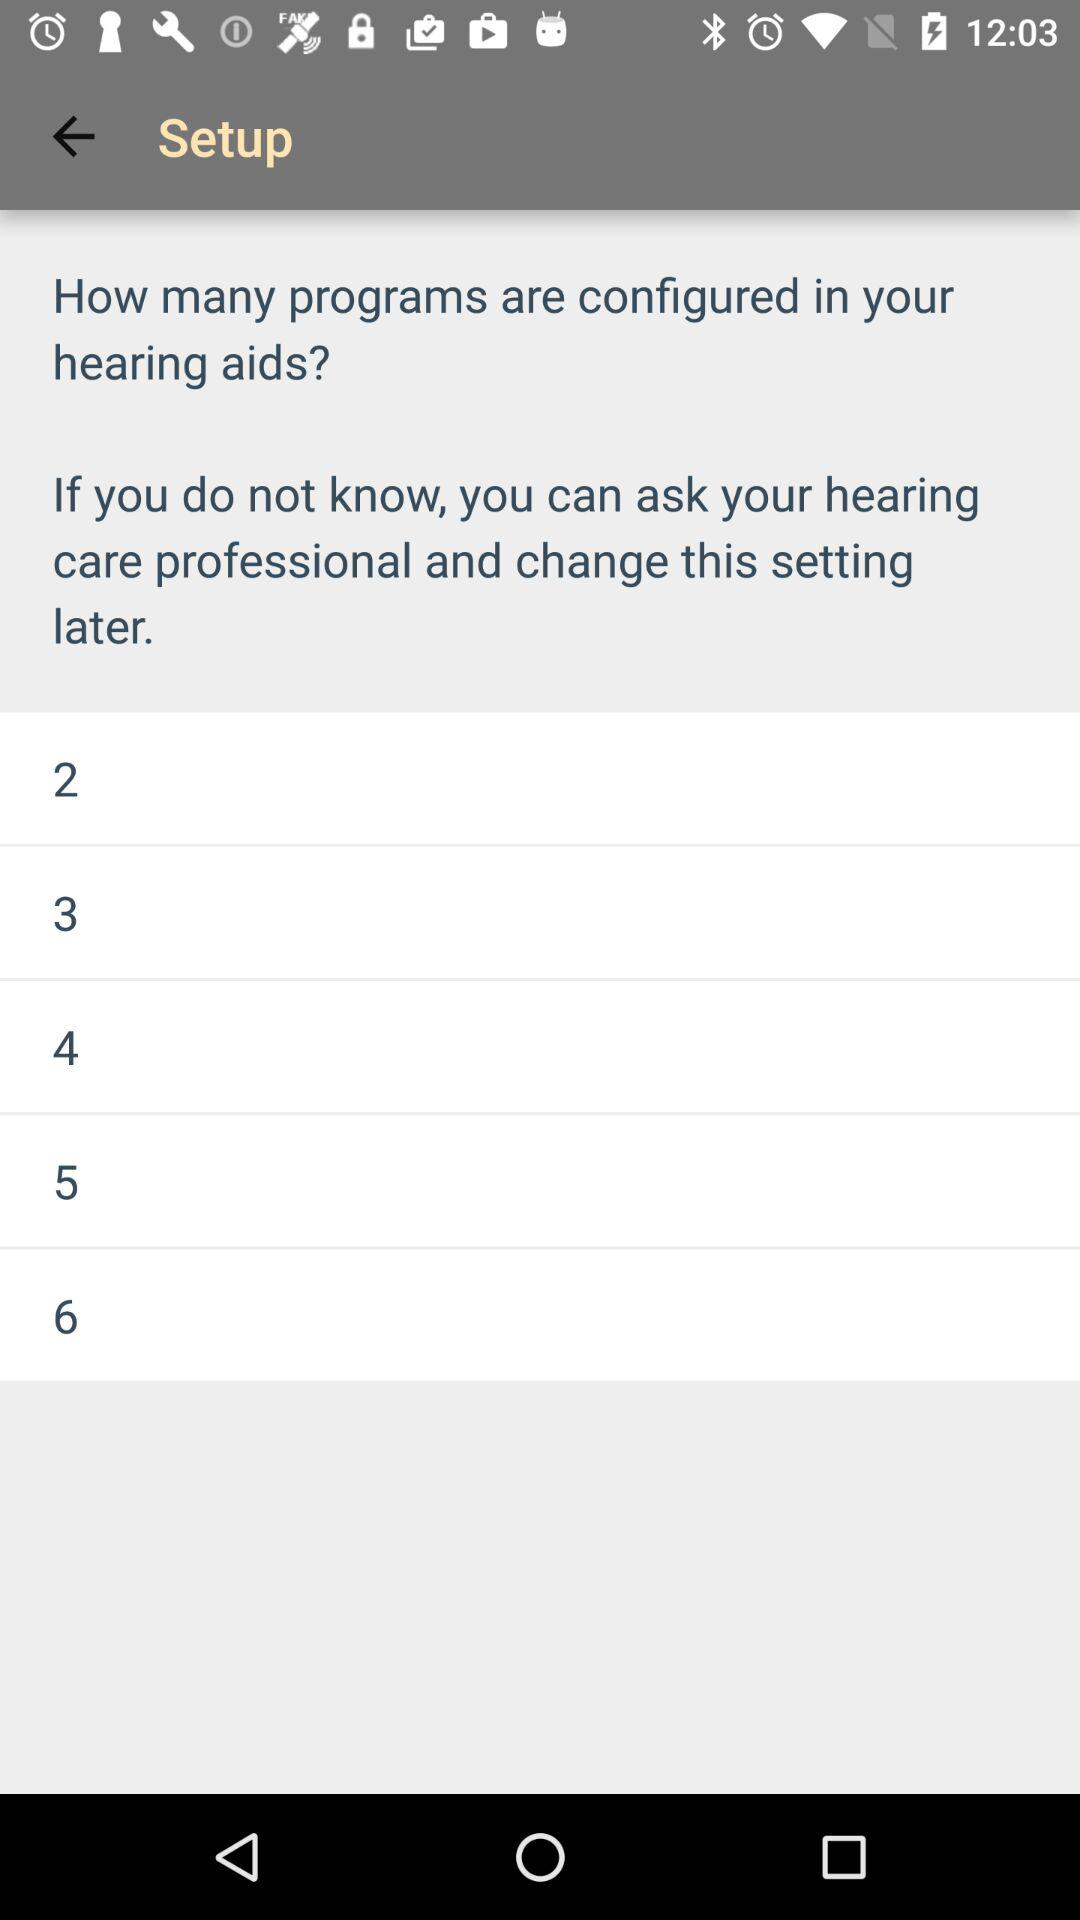How many programs are available?
Answer the question using a single word or phrase. 6 